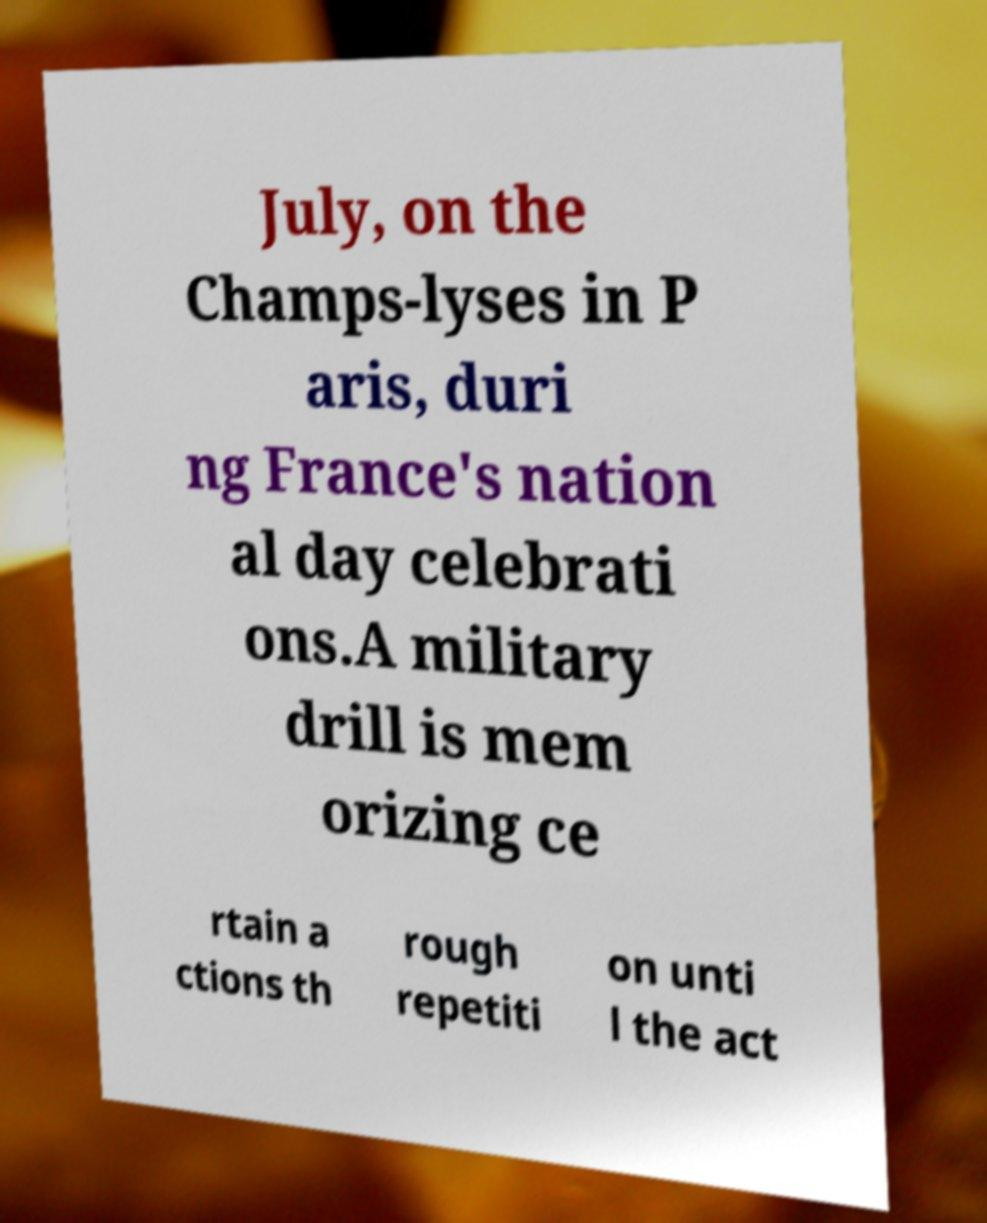What messages or text are displayed in this image? I need them in a readable, typed format. July, on the Champs-lyses in P aris, duri ng France's nation al day celebrati ons.A military drill is mem orizing ce rtain a ctions th rough repetiti on unti l the act 